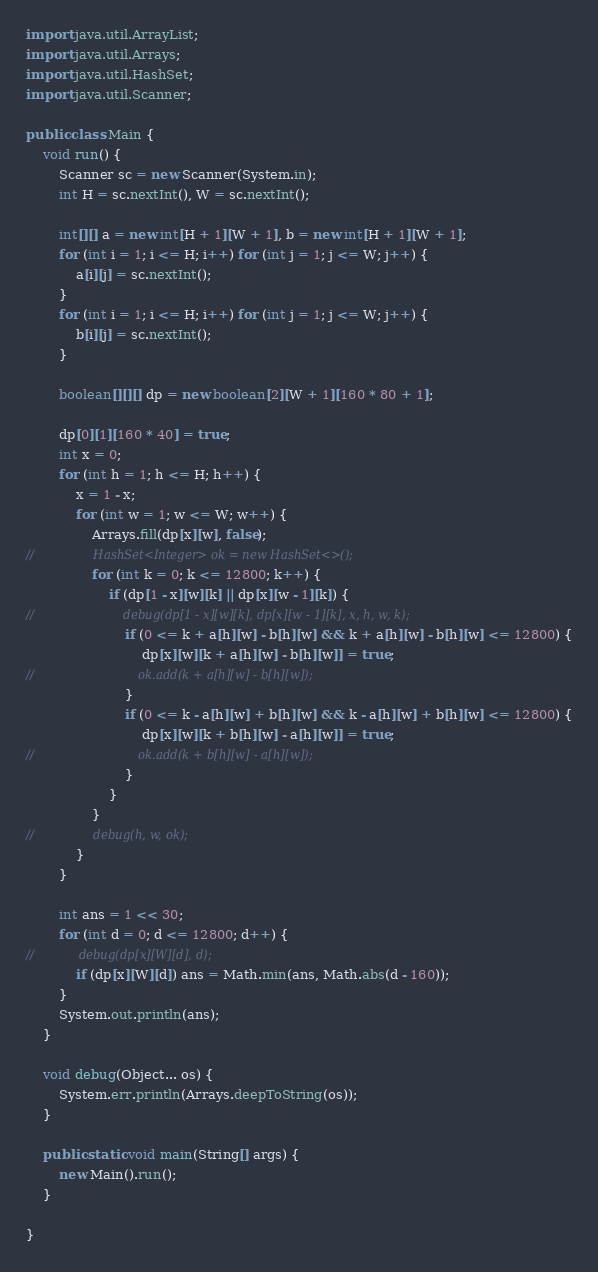Convert code to text. <code><loc_0><loc_0><loc_500><loc_500><_Java_>
import java.util.ArrayList;
import java.util.Arrays;
import java.util.HashSet;
import java.util.Scanner;

public class Main {
    void run() {
        Scanner sc = new Scanner(System.in);
        int H = sc.nextInt(), W = sc.nextInt();

        int[][] a = new int[H + 1][W + 1], b = new int[H + 1][W + 1];
        for (int i = 1; i <= H; i++) for (int j = 1; j <= W; j++) {
            a[i][j] = sc.nextInt();
        }
        for (int i = 1; i <= H; i++) for (int j = 1; j <= W; j++) {
            b[i][j] = sc.nextInt();
        }

        boolean[][][] dp = new boolean[2][W + 1][160 * 80 + 1];

        dp[0][1][160 * 40] = true;
        int x = 0;
        for (int h = 1; h <= H; h++) {
            x = 1 - x;
            for (int w = 1; w <= W; w++) {
                Arrays.fill(dp[x][w], false);
//                HashSet<Integer> ok = new HashSet<>();
                for (int k = 0; k <= 12800; k++) {
                    if (dp[1 - x][w][k] || dp[x][w - 1][k]) {
//                        debug(dp[1 - x][w][k], dp[x][w - 1][k], x, h, w, k);
                        if (0 <= k + a[h][w] - b[h][w] && k + a[h][w] - b[h][w] <= 12800) {
                            dp[x][w][k + a[h][w] - b[h][w]] = true;
//                            ok.add(k + a[h][w] - b[h][w]);
                        }
                        if (0 <= k - a[h][w] + b[h][w] && k - a[h][w] + b[h][w] <= 12800) {
                            dp[x][w][k + b[h][w] - a[h][w]] = true;
//                            ok.add(k + b[h][w] - a[h][w]);
                        }
                    }
                }
//                debug(h, w, ok);
            }
        }

        int ans = 1 << 30;
        for (int d = 0; d <= 12800; d++) {
//            debug(dp[x][W][d], d);
            if (dp[x][W][d]) ans = Math.min(ans, Math.abs(d - 160));
        }
        System.out.println(ans);
    }

    void debug(Object... os) {
        System.err.println(Arrays.deepToString(os));
    }

    public static void main(String[] args) {
        new Main().run();
    }

}
</code> 